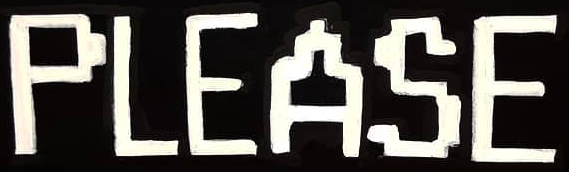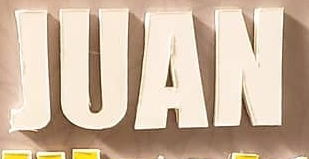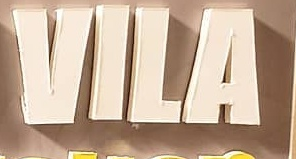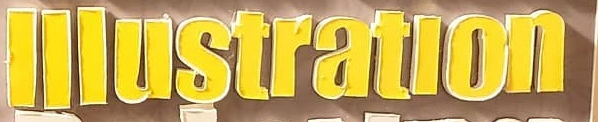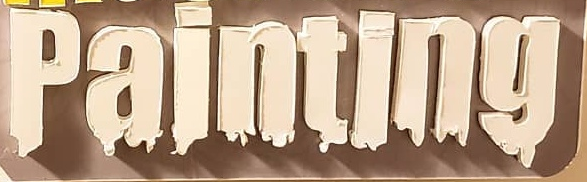Transcribe the words shown in these images in order, separated by a semicolon. PLEASE; JUAN; VILA; lllustratlon; painting 